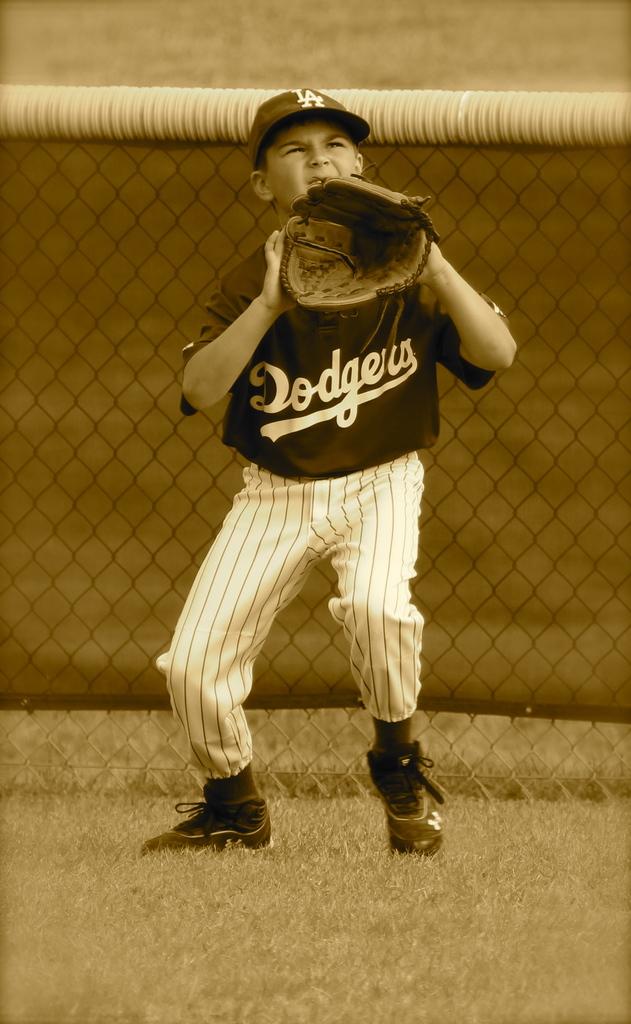What team does the player play for?
Make the answer very short. Dodgers. 